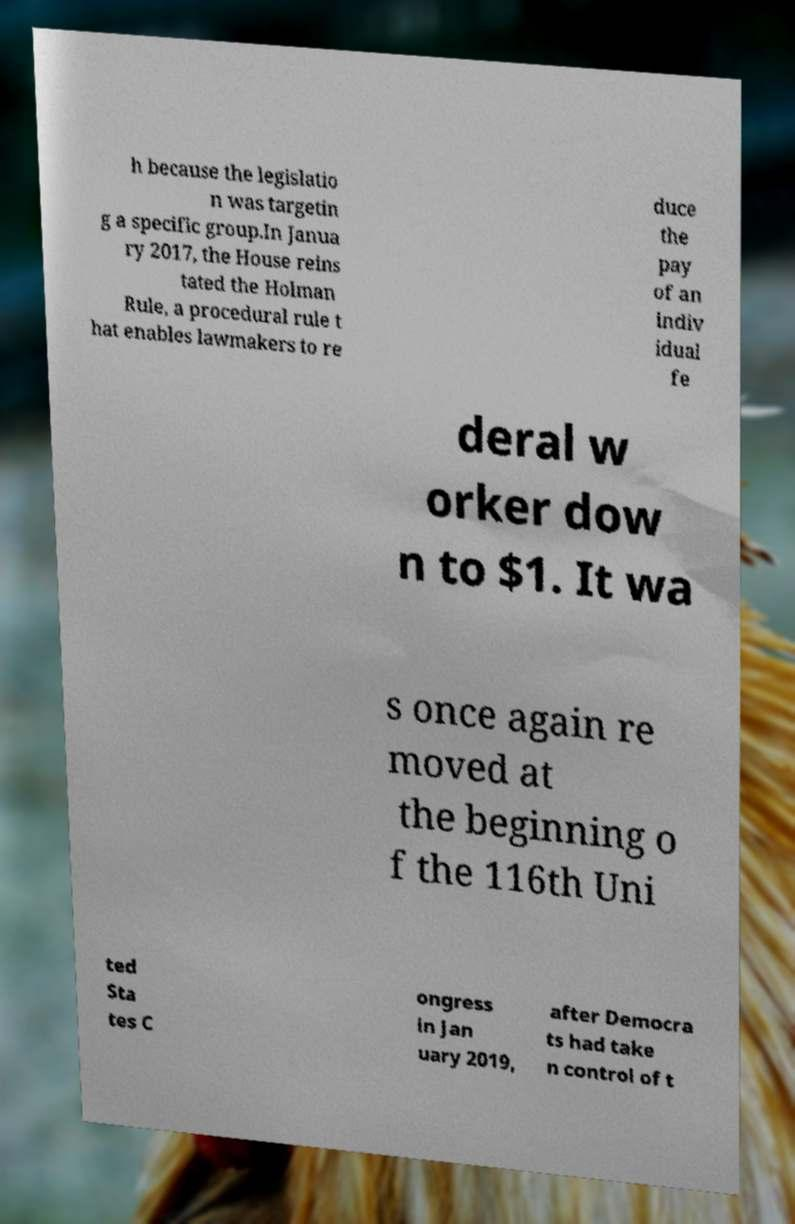Please read and relay the text visible in this image. What does it say? h because the legislatio n was targetin g a specific group.In Janua ry 2017, the House reins tated the Holman Rule, a procedural rule t hat enables lawmakers to re duce the pay of an indiv idual fe deral w orker dow n to $1. It wa s once again re moved at the beginning o f the 116th Uni ted Sta tes C ongress in Jan uary 2019, after Democra ts had take n control of t 